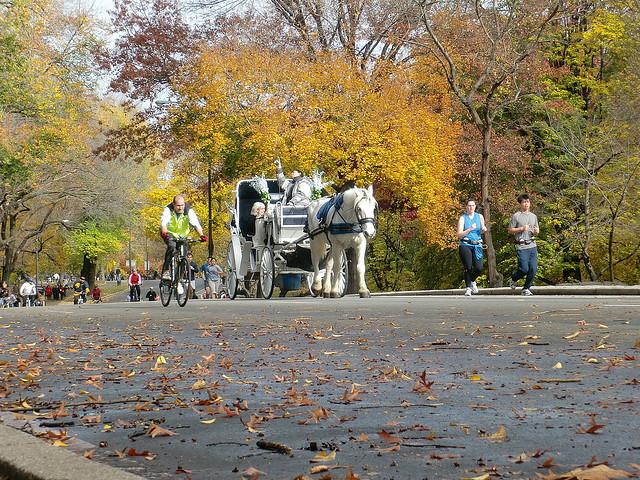Are leaves on the ground?
Be succinct. Yes. What season of the year is it?
Short answer required. Fall. Who is going faster?
Be succinct. Horse. What type of animal is on the road?
Keep it brief. Horse. 